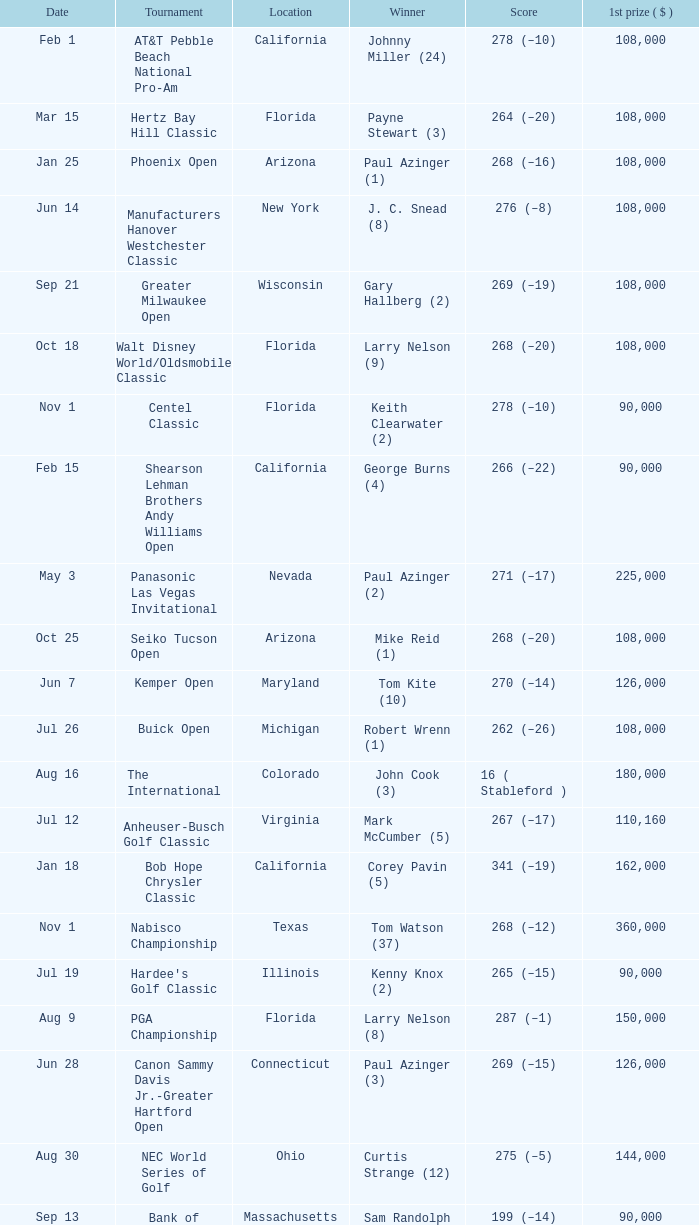What is the date where the winner was Tom Kite (10)? Jun 7. 